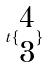Convert formula to latex. <formula><loc_0><loc_0><loc_500><loc_500>t \{ \begin{matrix} 4 \\ 3 \end{matrix} \}</formula> 